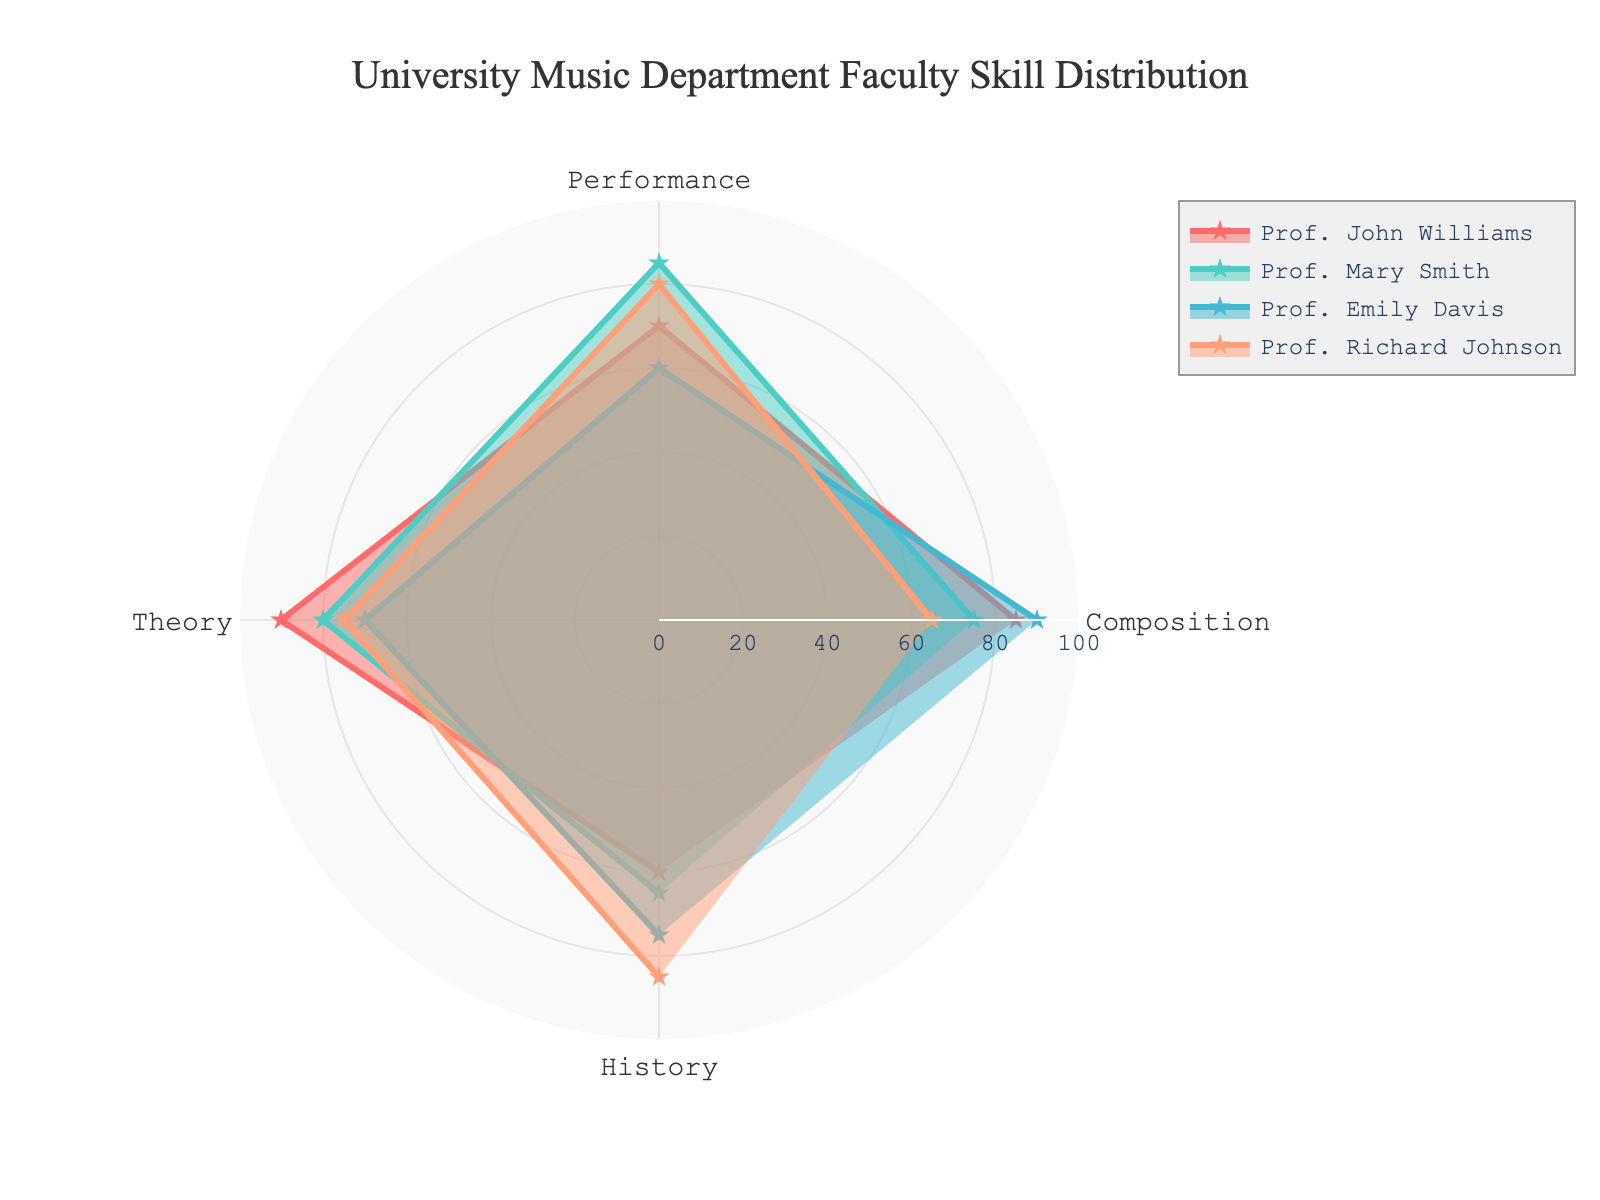What's the title of the figure? The title is typically located at the top of the figure. By examining the top section of the radar chart, we can see the title.
Answer: University Music Department Faculty Skill Distribution What are the four skill categories displayed in the radar chart? The categories are indicated along the axis of the radar chart. By observing these labels, we can identify all four categories.
Answer: Composition, Performance, Theory, History Which professor scores the highest in Composition? By comparing the Composition scores of all professors, we can identify the highest value. Prof. Emily Davis has the highest score in Composition.
Answer: Prof. Emily Davis Which professor has the lowest score in Performance? By reviewing the scores under the Performance category for each professor, we see that Prof. Emily Davis has the lowest score.
Answer: Prof. Emily Davis What is the average Theory score for all professors? First, sum the Theory scores (90 + 80 + 70 + 75 = 315) and then divide by the number of professors (4). The average is 315/4.
Answer: 78.75 Compare Prof. John Williams and Prof. Mary Smith in Performance. Who has a higher score? By comparing the Performance scores of the two professors, we see that Prof. Mary Smith has 85, which is higher than Prof. John Williams' 70.
Answer: Prof. Mary Smith Which professor shows the most balanced skills across all categories? A professor with balanced skills would have similar (or close) values across all categories, forming a more regular shape on the radar chart. Prof. Richard Johnson seems most balanced with scores of 65, 80, 75, and 85.
Answer: Prof. Richard Johnson Which category does Prof. Richard Johnson score highest in? By examining Prof. Richard Johnson's scores across all categories, we observe that the highest value is in History (85).
Answer: History What's the combined score in History for all professors? Adding all the History scores together (60 + 65 + 75 + 85 = 285) provides the total.
Answer: 285 What is the difference between the highest and lowest Theory scores? The highest Theory score is 90 (Prof. John Williams), and the lowest is 70 (Prof. Emily Davis). The difference is 90 - 70.
Answer: 20 